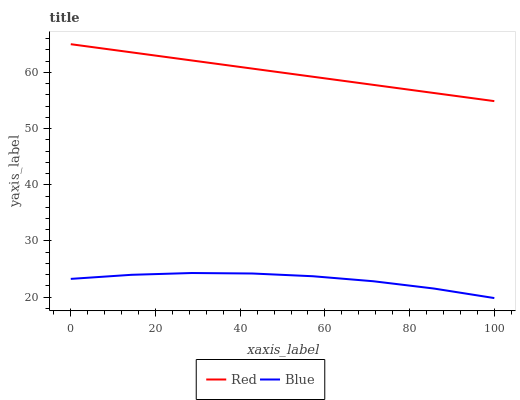Does Blue have the minimum area under the curve?
Answer yes or no. Yes. Does Red have the maximum area under the curve?
Answer yes or no. Yes. Does Red have the minimum area under the curve?
Answer yes or no. No. Is Red the smoothest?
Answer yes or no. Yes. Is Blue the roughest?
Answer yes or no. Yes. Is Red the roughest?
Answer yes or no. No. Does Blue have the lowest value?
Answer yes or no. Yes. Does Red have the lowest value?
Answer yes or no. No. Does Red have the highest value?
Answer yes or no. Yes. Is Blue less than Red?
Answer yes or no. Yes. Is Red greater than Blue?
Answer yes or no. Yes. Does Blue intersect Red?
Answer yes or no. No. 